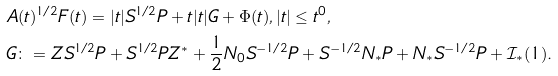<formula> <loc_0><loc_0><loc_500><loc_500>& A ( t ) ^ { 1 / 2 } F ( t ) = | t | S ^ { 1 / 2 } P + t | t | G + \Phi ( t ) , | t | \leq t ^ { 0 } , \\ & G \colon = Z S ^ { 1 / 2 } P + S ^ { 1 / 2 } P Z ^ { * } + \frac { 1 } { 2 } N _ { 0 } S ^ { - 1 / 2 } P + S ^ { - 1 / 2 } N _ { * } P + N _ { * } S ^ { - 1 / 2 } P + \mathcal { I } _ { * } ( 1 ) .</formula> 